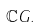Convert formula to latex. <formula><loc_0><loc_0><loc_500><loc_500>\mathbb { C } G .</formula> 